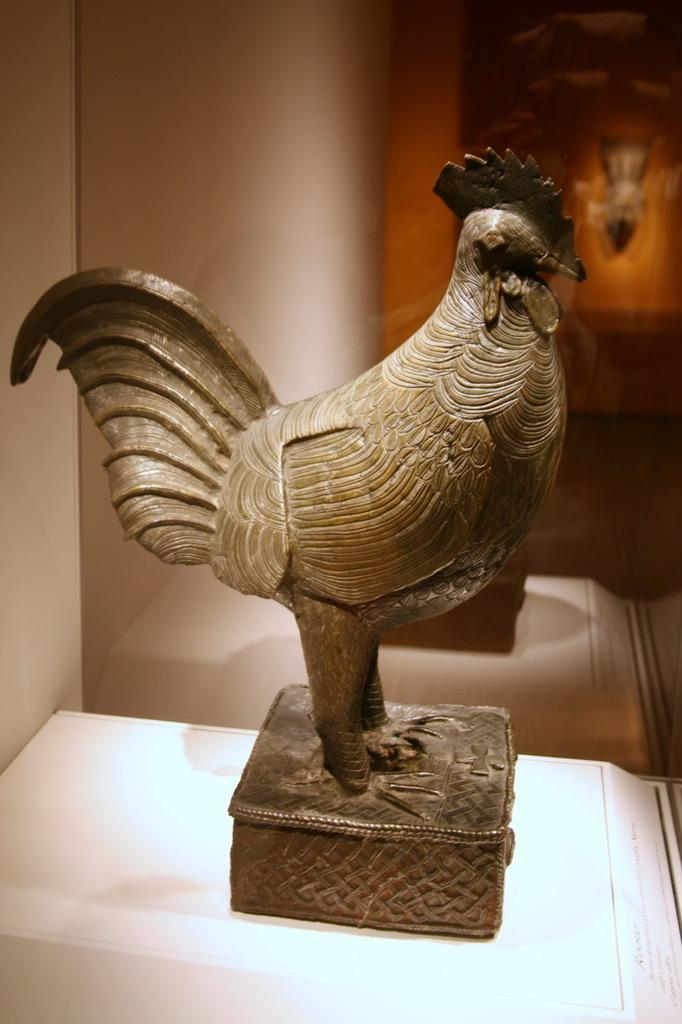What is the main subject of the image? There is a sculpture of a rooster in the image. Where is the sculpture located? The sculpture is placed on a table. What can be seen in the background of the image? There is a wall in the background of the image. Is the image taken indoors or outdoors? The image is an inside view. What type of gun is the queen holding in the image? There is no queen or gun present in the image; it features a sculpture of a rooster on a table. 